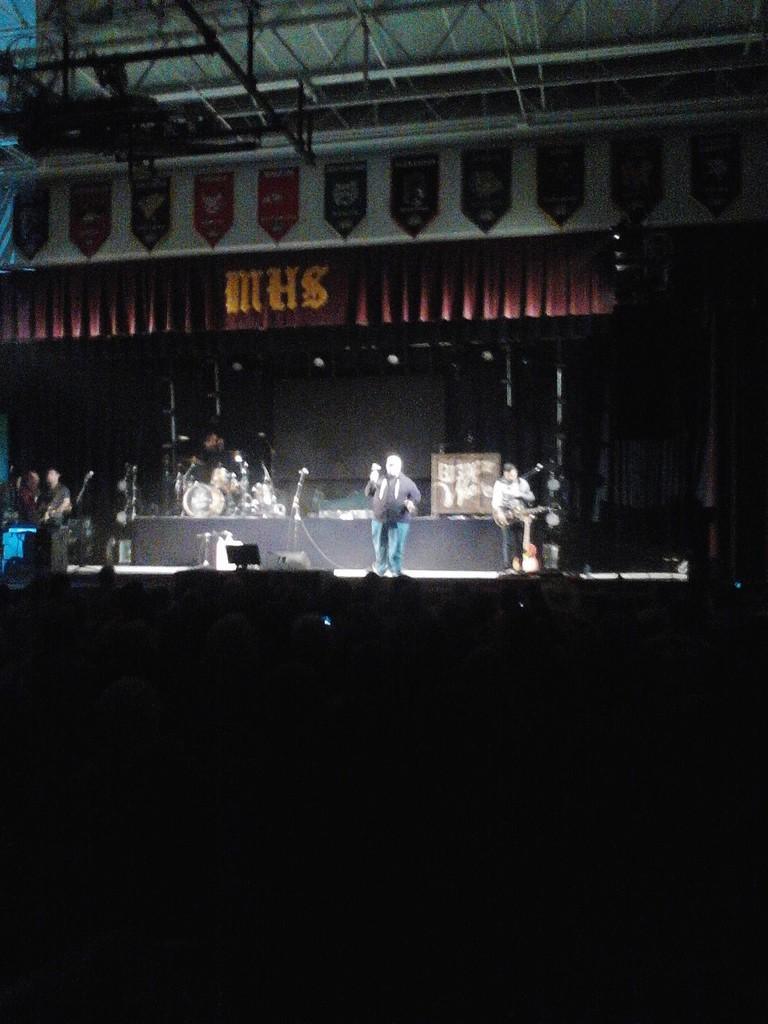What is the lighting condition at the bottom of the image? The bottom of the image is dark. What is happening in the middle of the image? There are persons performing on a stage in the middle of the image. What is located at the top of the image? There is a roof at the top of the image. Are there any icicles hanging from the roof in the image? There is no mention of icicles in the provided facts, so we cannot determine if any are present in the image. What type of food is being served to the audience in the image? There is no mention of food being served in the image, so we cannot determine what type of food might be present. 